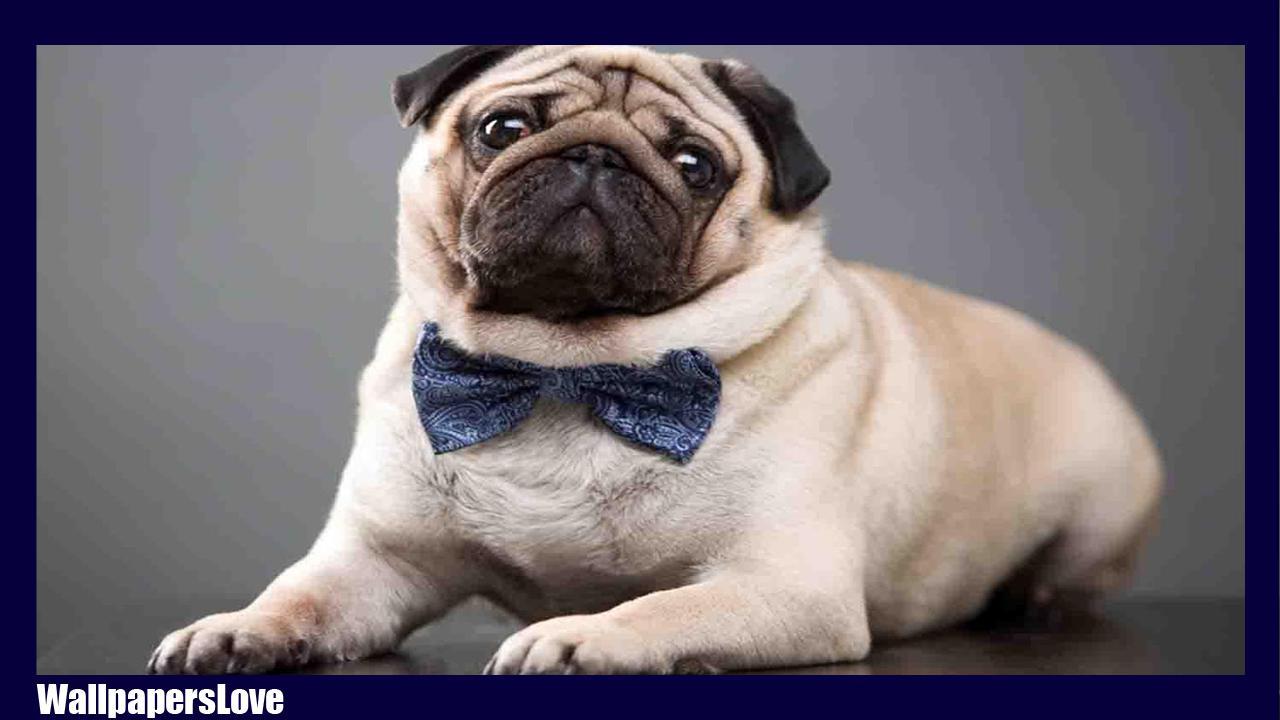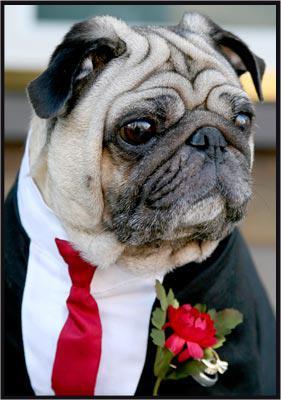The first image is the image on the left, the second image is the image on the right. Considering the images on both sides, is "At least one pug is wearing somehing on its neck." valid? Answer yes or no. Yes. The first image is the image on the left, the second image is the image on the right. Analyze the images presented: Is the assertion "The left image shows one pug reclining on its belly with its front paws forward and its head upright." valid? Answer yes or no. Yes. 